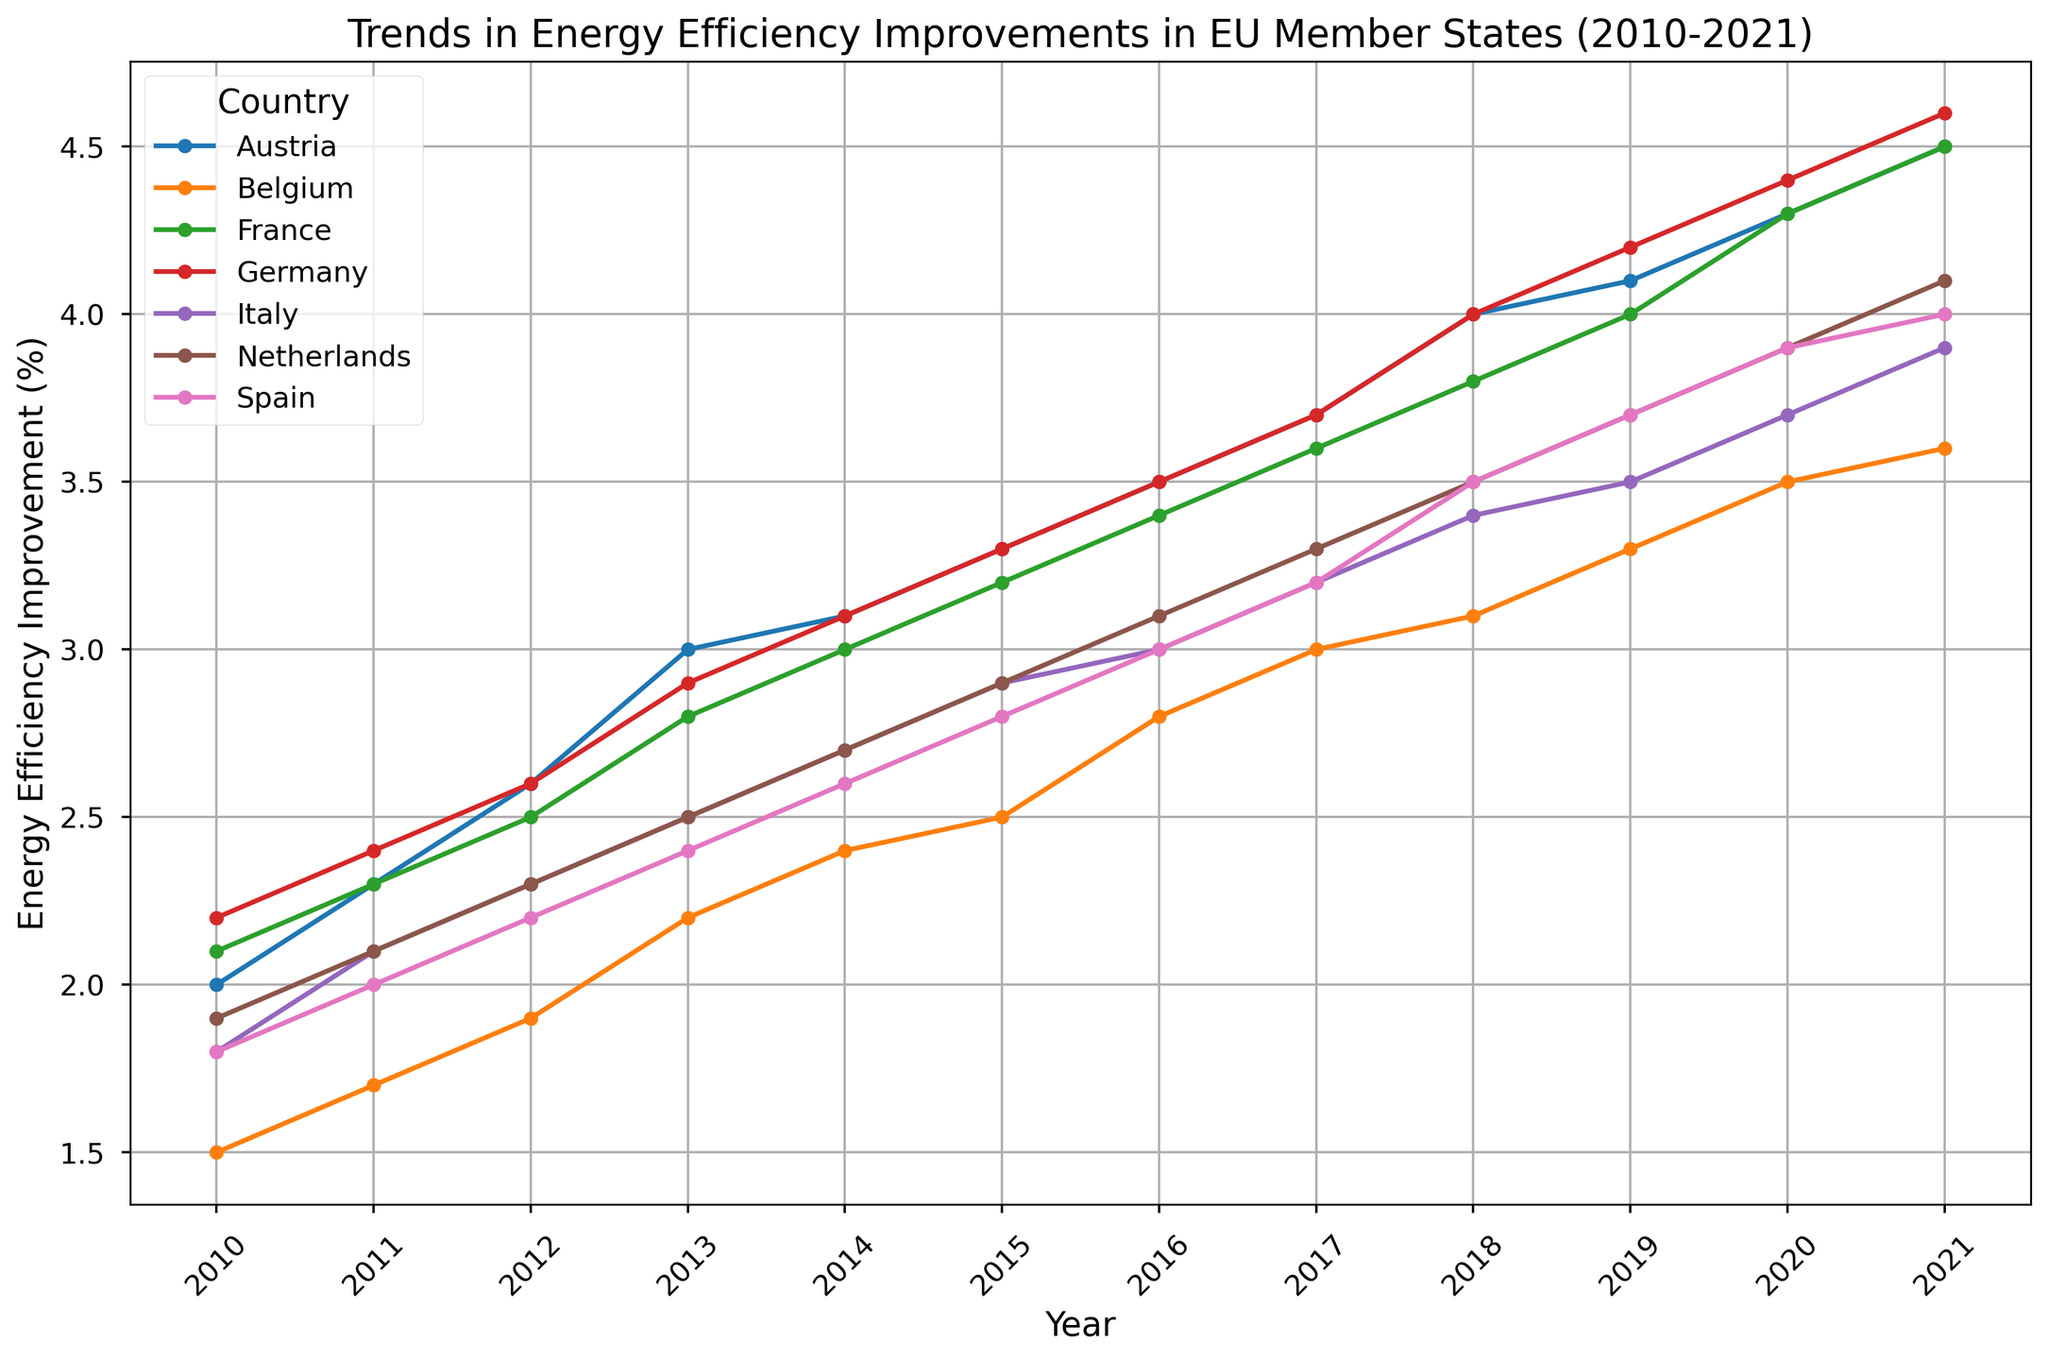What is the highest energy efficiency improvement percentage achieved by any country in 2021? First, locate the year 2021 on the x-axis of the figure. Then, identify the highest point on the y-axis for this year. Germany has the highest point in 2021 with an efficiency improvement of 4.6%
Answer: 4.6% Which country showed the most consistent increase in energy efficiency improvement from 2010 to 2021? Look for the lines in the chart and observe which one has a steady, positive slope with no major dips. Most lines indicate consistent improvement, but Germany's and France's lines appear smooth and steadily increasing.
Answer: Germany or France Compare the energy efficiency improvement percentage of Austria and Belgium in 2015. Which country had a higher value, and what is the difference? Locate the year 2015 on the x-axis and find the corresponding points for Austria and Belgium on the y-axis. Austria is at 3.3%, and Belgium is at 2.5%. The difference is 3.3% - 2.5% = 0.8%.
Answer: Austria, 0.8% Did any country achieve the same energy efficiency improvement in any given year? Scan the chart for any overlapping points across different countries in the same year. France and Austria both had a 4.5% improvement in 2021.
Answer: Yes, France and Austria in 2021 Between 2010 and 2021, which country had the largest increase in energy efficiency improvement percentage? Evaluate the difference between the 2010 and 2021 values for each country. Germany starts at 2.2% and ends at 4.6%, an increase of 2.4%, the highest among all countries.
Answer: Germany What was the trend in energy efficiency improvement for Spain from 2010 to 2021? Follow Spain's line from 2010 to 2021. The line shows a consistent upward trend from 1.8% in 2010 to 4.0% in 2021 with no declines.
Answer: Consistent upward trend How does Italy's energy efficiency improvement in 2017 compare to its performance in 2021? Locate Italy's points for the years 2017 and 2021 on the x-axis and compare. In 2017, Italy is at 3.2% and in 2021, it is at 3.9%. The 2021 value is higher by 0.7%.
Answer: 2021 is higher by 0.7% What is the average energy efficiency improvement percentage for Austria over the period 2010-2021? Sum up all percentages from 2010 to 2021 for Austria (2.0 + 2.3 + 2.6 + 3.0 + 3.1 + 3.3 + 3.5 + 3.7 + 4.0 + 4.1 + 4.3 + 4.5 = 40.4) and divide by the number of years (12). The average is 40.4/12 = 3.37%.
Answer: 3.37% Which country had the smallest percentage increase in energy efficiency improvements from 2010 to 2021? Find the difference between the 2021 and 2010 values for each country. Belgium has the smallest increase from 1.5% to 3.6%, which is an increase of 2.1%.
Answer: Belgium 